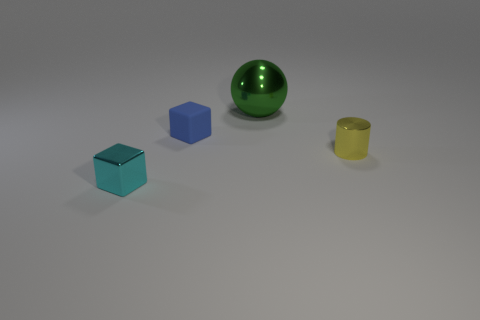Add 3 green matte blocks. How many objects exist? 7 Subtract all cylinders. How many objects are left? 3 Subtract all purple rubber spheres. Subtract all blue cubes. How many objects are left? 3 Add 4 rubber things. How many rubber things are left? 5 Add 1 large shiny things. How many large shiny things exist? 2 Subtract 0 red spheres. How many objects are left? 4 